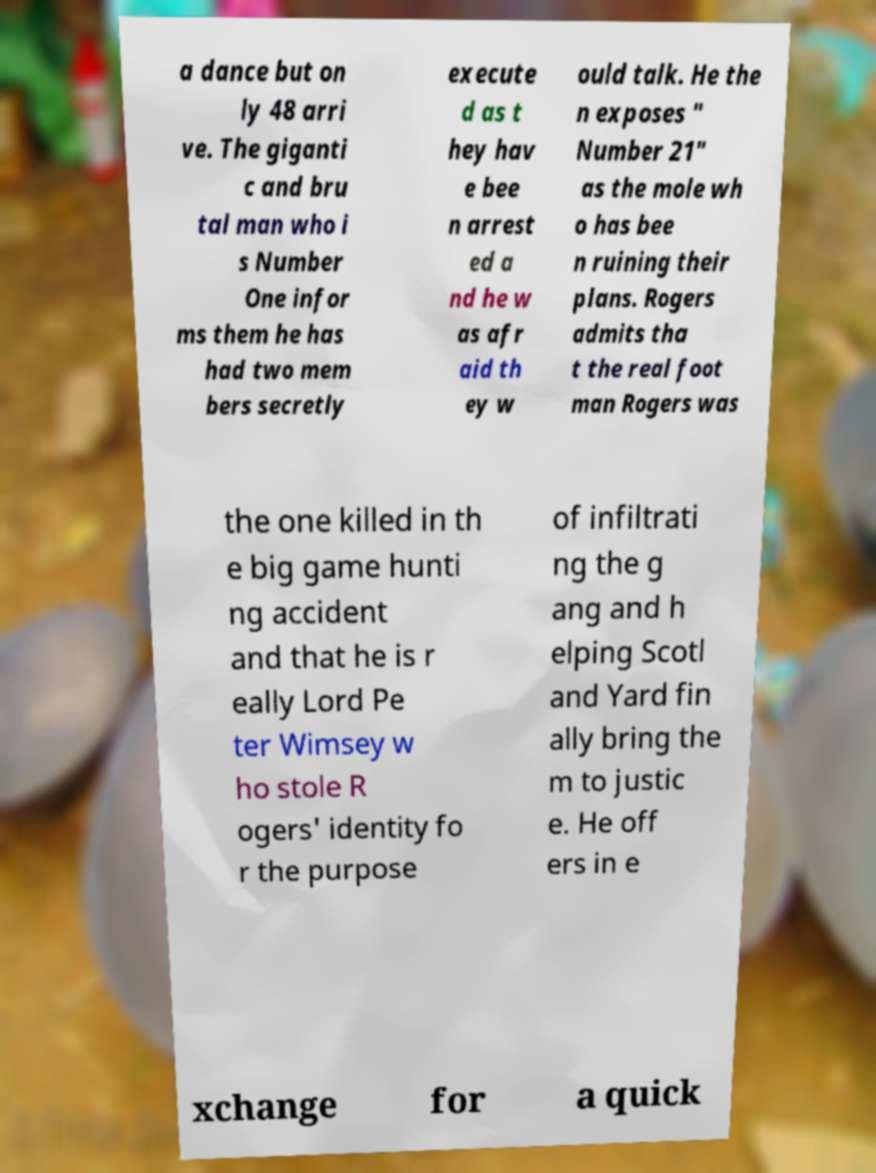Can you read and provide the text displayed in the image?This photo seems to have some interesting text. Can you extract and type it out for me? a dance but on ly 48 arri ve. The giganti c and bru tal man who i s Number One infor ms them he has had two mem bers secretly execute d as t hey hav e bee n arrest ed a nd he w as afr aid th ey w ould talk. He the n exposes " Number 21" as the mole wh o has bee n ruining their plans. Rogers admits tha t the real foot man Rogers was the one killed in th e big game hunti ng accident and that he is r eally Lord Pe ter Wimsey w ho stole R ogers' identity fo r the purpose of infiltrati ng the g ang and h elping Scotl and Yard fin ally bring the m to justic e. He off ers in e xchange for a quick 